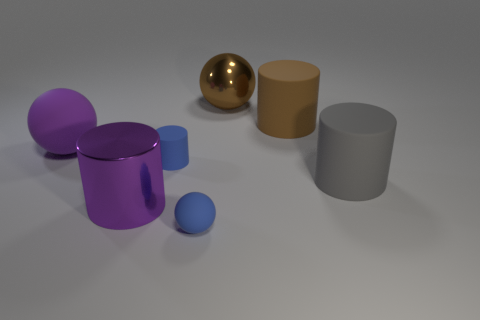Subtract all blue cylinders. How many cylinders are left? 3 Add 3 small green shiny spheres. How many objects exist? 10 Subtract all blue balls. How many balls are left? 2 Subtract all cylinders. How many objects are left? 3 Subtract all red shiny cylinders. Subtract all gray things. How many objects are left? 6 Add 5 blue cylinders. How many blue cylinders are left? 6 Add 6 small purple matte spheres. How many small purple matte spheres exist? 6 Subtract 0 green blocks. How many objects are left? 7 Subtract all gray cylinders. Subtract all purple blocks. How many cylinders are left? 3 